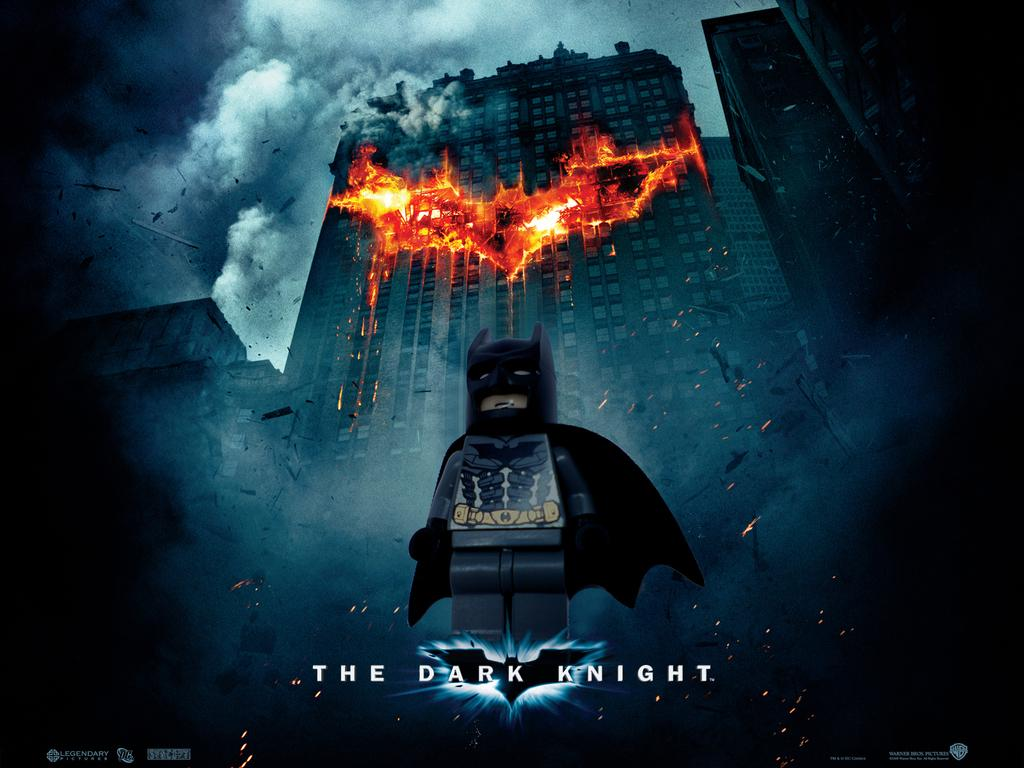<image>
Write a terse but informative summary of the picture. A  poster from the movie The Dark Knight in front of the burning building. 